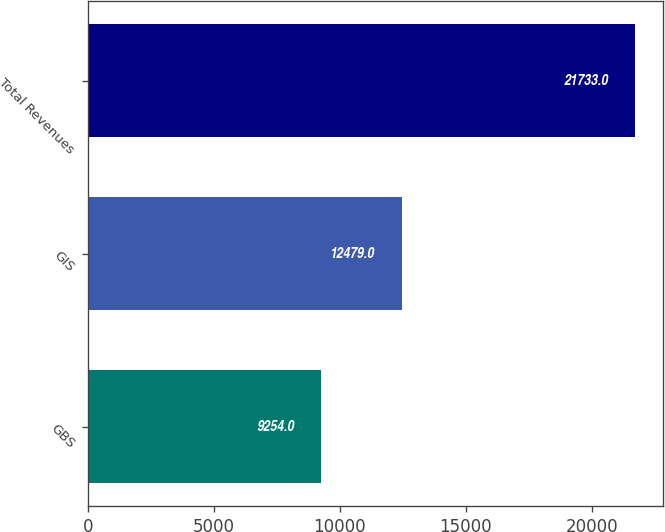<chart> <loc_0><loc_0><loc_500><loc_500><bar_chart><fcel>GBS<fcel>GIS<fcel>Total Revenues<nl><fcel>9254<fcel>12479<fcel>21733<nl></chart> 